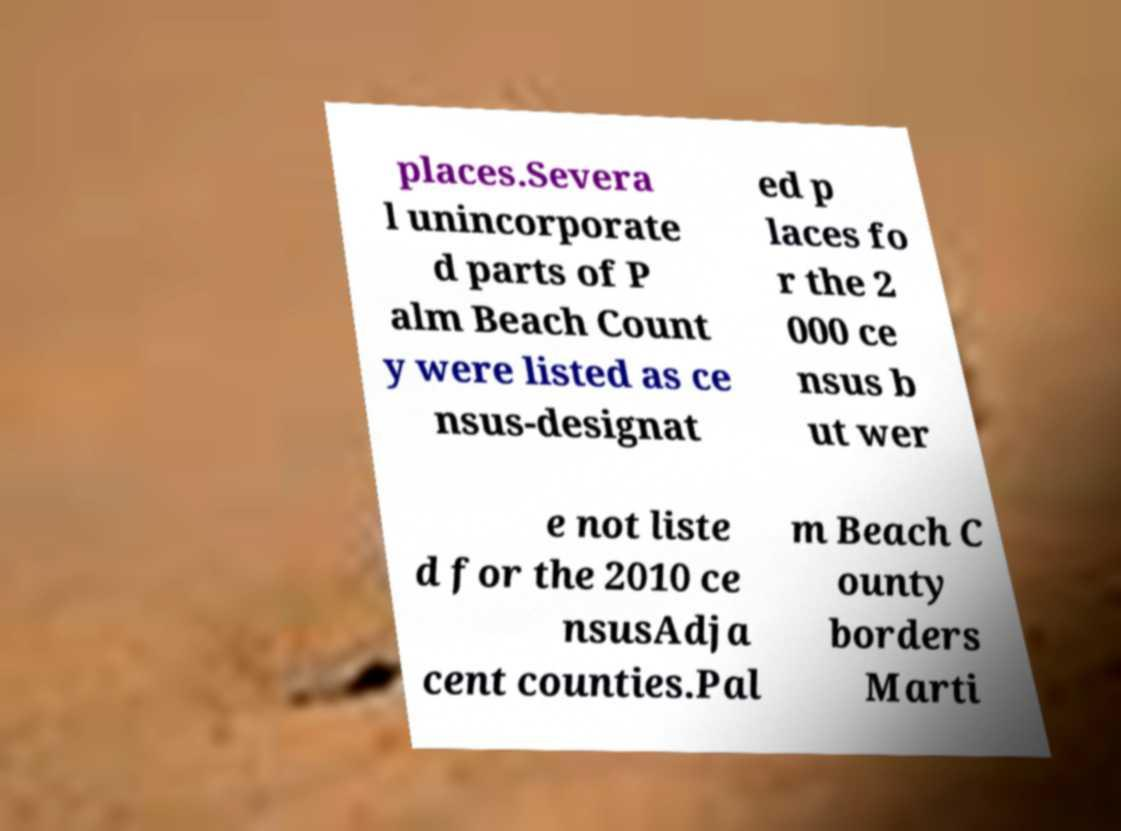What messages or text are displayed in this image? I need them in a readable, typed format. places.Severa l unincorporate d parts of P alm Beach Count y were listed as ce nsus-designat ed p laces fo r the 2 000 ce nsus b ut wer e not liste d for the 2010 ce nsusAdja cent counties.Pal m Beach C ounty borders Marti 